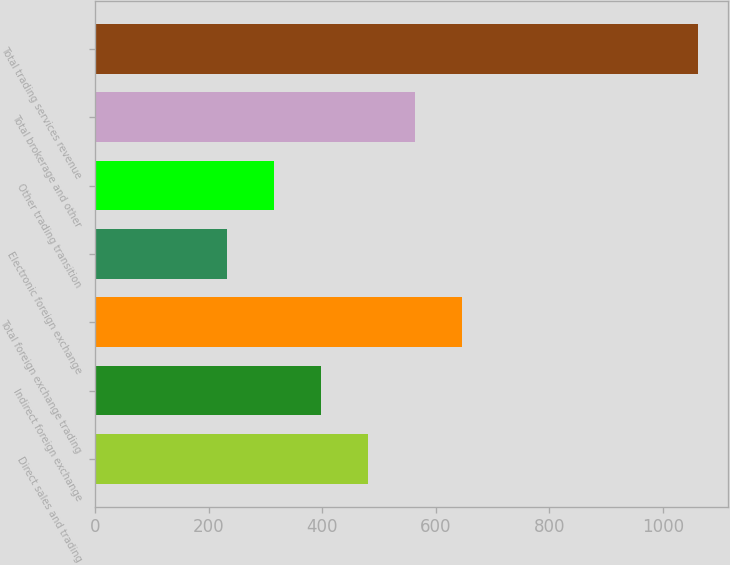Convert chart to OTSL. <chart><loc_0><loc_0><loc_500><loc_500><bar_chart><fcel>Direct sales and trading<fcel>Indirect foreign exchange<fcel>Total foreign exchange trading<fcel>Electronic foreign exchange<fcel>Other trading transition<fcel>Total brokerage and other<fcel>Total trading services revenue<nl><fcel>481.4<fcel>398.6<fcel>647<fcel>233<fcel>315.8<fcel>564.2<fcel>1061<nl></chart> 